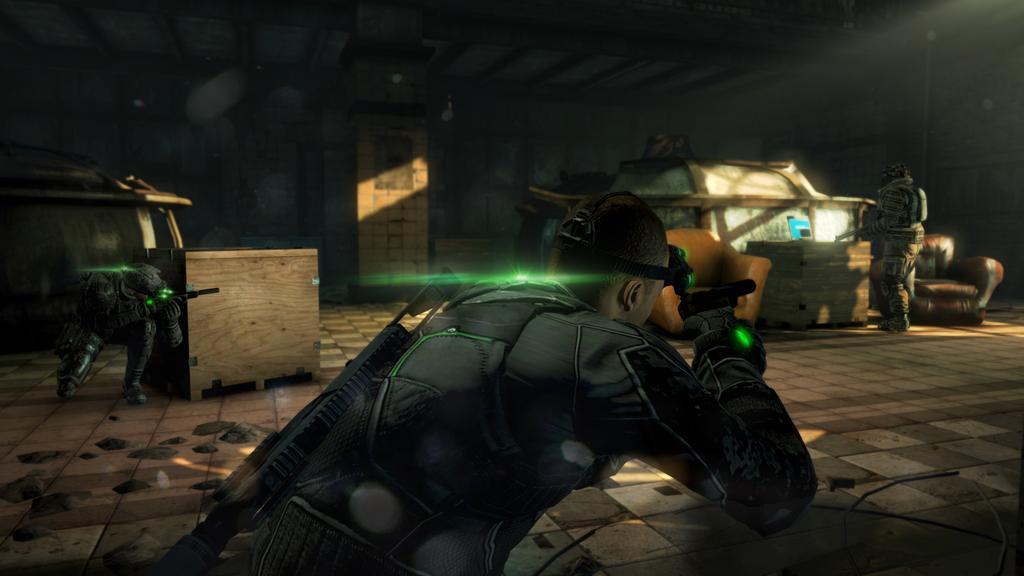Describe this image in one or two sentences. This picture shows the inner view of a building. This is an animated image, there are three persons, some objects are on the surface, two big wooden boxes, two Sofa chairs, two persons holding guns and some objects attached to the wall. 